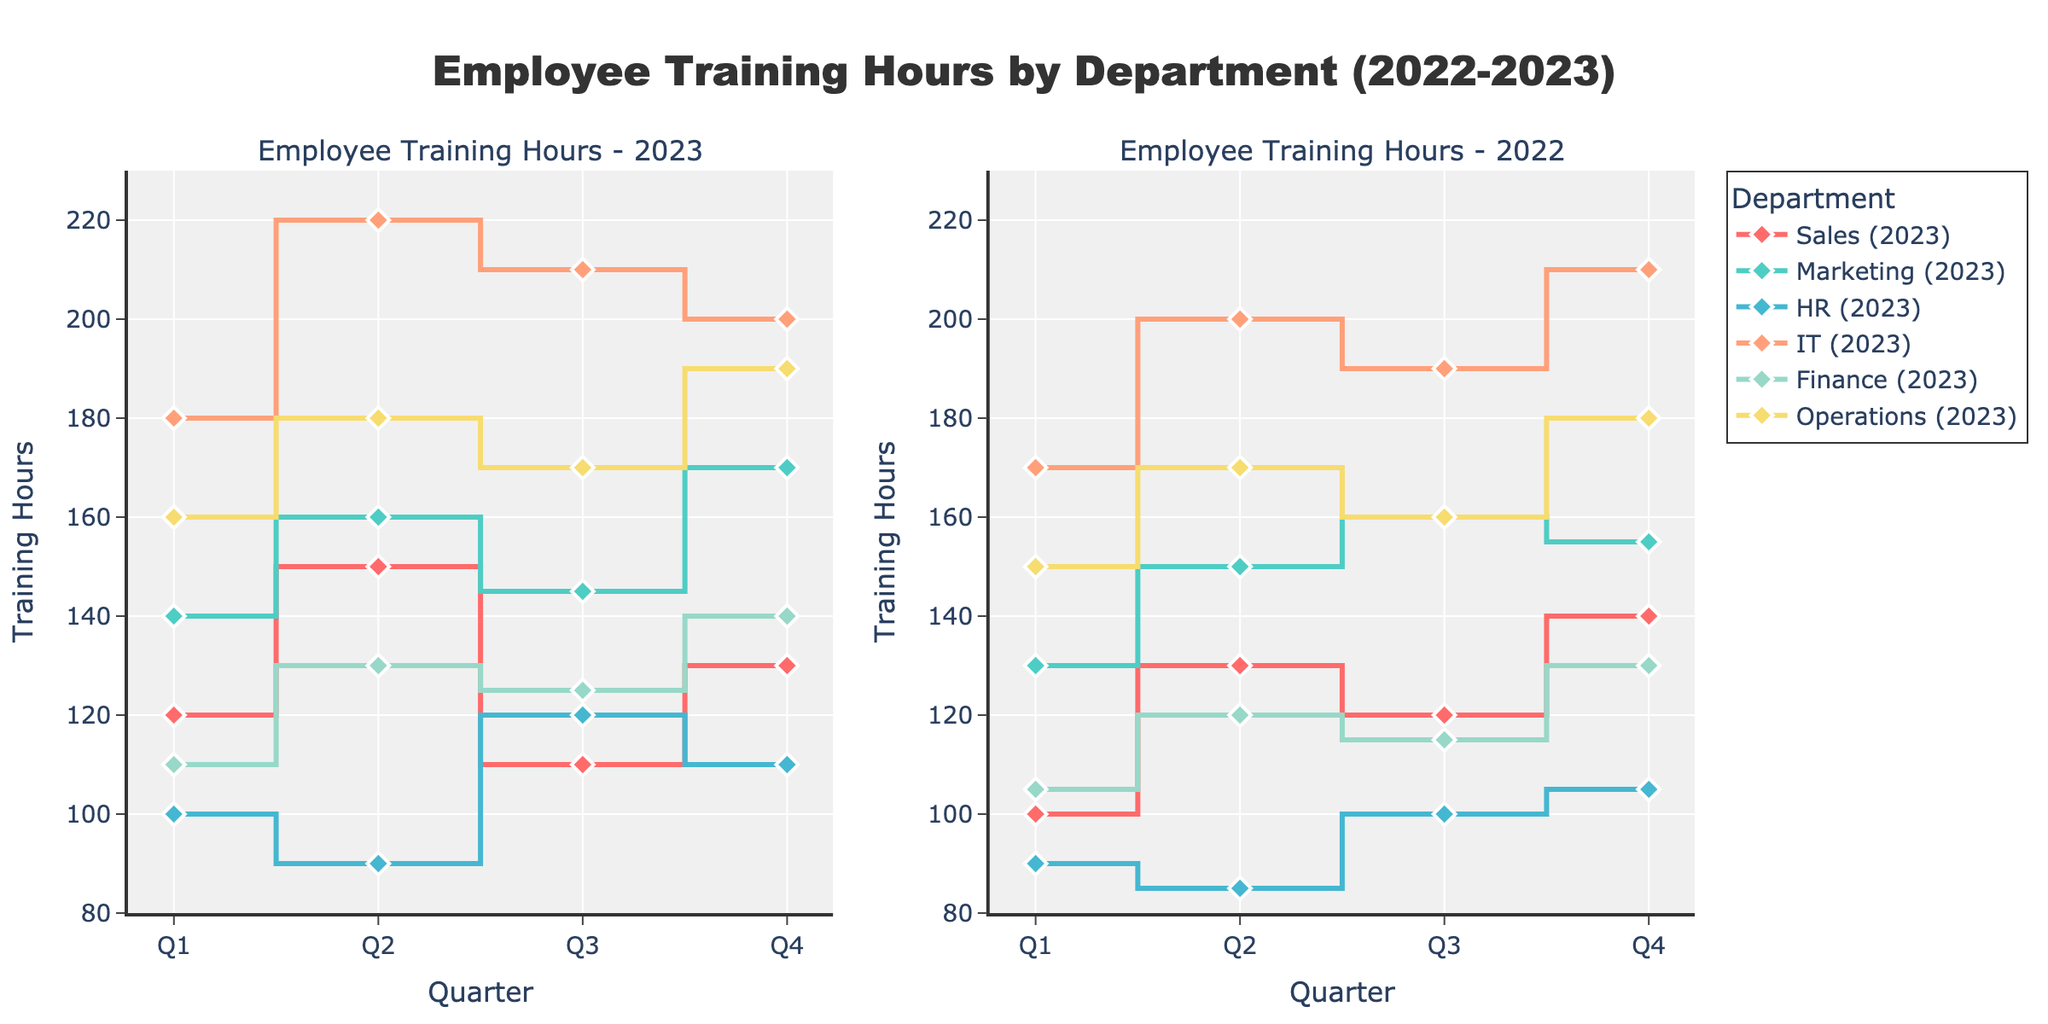Which year had higher total training hours in the Sales department? Add up the training hours for each quarter for Sales in both years. For 2022, it's 100+130+120+140=490, and for 2023, it's 120+150+110+130=510. Compare the totals to determine the answer.
Answer: 2023 In 2023, which department had the lowest training hours in Q2? Look at the training hours for Q2 in 2023 across all departments. Identify the lowest value, which belongs to HR with 90 hours.
Answer: HR Between 2022 and 2023, did the IT department's training hours in Q3 increase or decrease? Compare the Q3 training hours for IT between the two years: 190 in 2022 and 210 in 2023. Determine if it increased or decreased.
Answer: Increase Which department showed the most significant decrease in training hours from Q1 to Q2 in 2023? Calculate the difference in training hours between Q1 and Q2 for each department in 2023. Sales: 30, Marketing: 20, HR: -10, IT: -40, Finance: 20, Operations: 20. The most significant decrease is in IT with -40 hours.
Answer: IT What is the average training hours per quarter for the Operations department in 2022? Sum the quarterly training hours for Operations in 2022: 150+170+160+180=660. Divide the total by the number of quarters (4). So, 660/4=165.
Answer: 165 Which two departments had exactly the same training hours in any quarter in 2023? Compare the training hours for all quarters across all departments in 2023. HR and Sales both have 110 hours in Q3.
Answer: HR and Sales How did the Finance department's training hours change from Q4 in 2022 to Q4 in 2023? Compare the Q4 training hours for Finance between the two years: 130 in 2022 and 140 in 2023. Calculate the difference: 140 - 130 = 10.
Answer: Increased by 10 What was the total training hours for the Marketing department across Q1 and Q2 in 2023? Add the training hours for Marketing in Q1 and Q2 in 2023: 140 + 160 = 300.
Answer: 300 During which quarter of 2023 did the HR department have the highest training hours? Look at the HR department's training hours for each quarter in 2023. The highest value is 120 in Q3.
Answer: Q3 